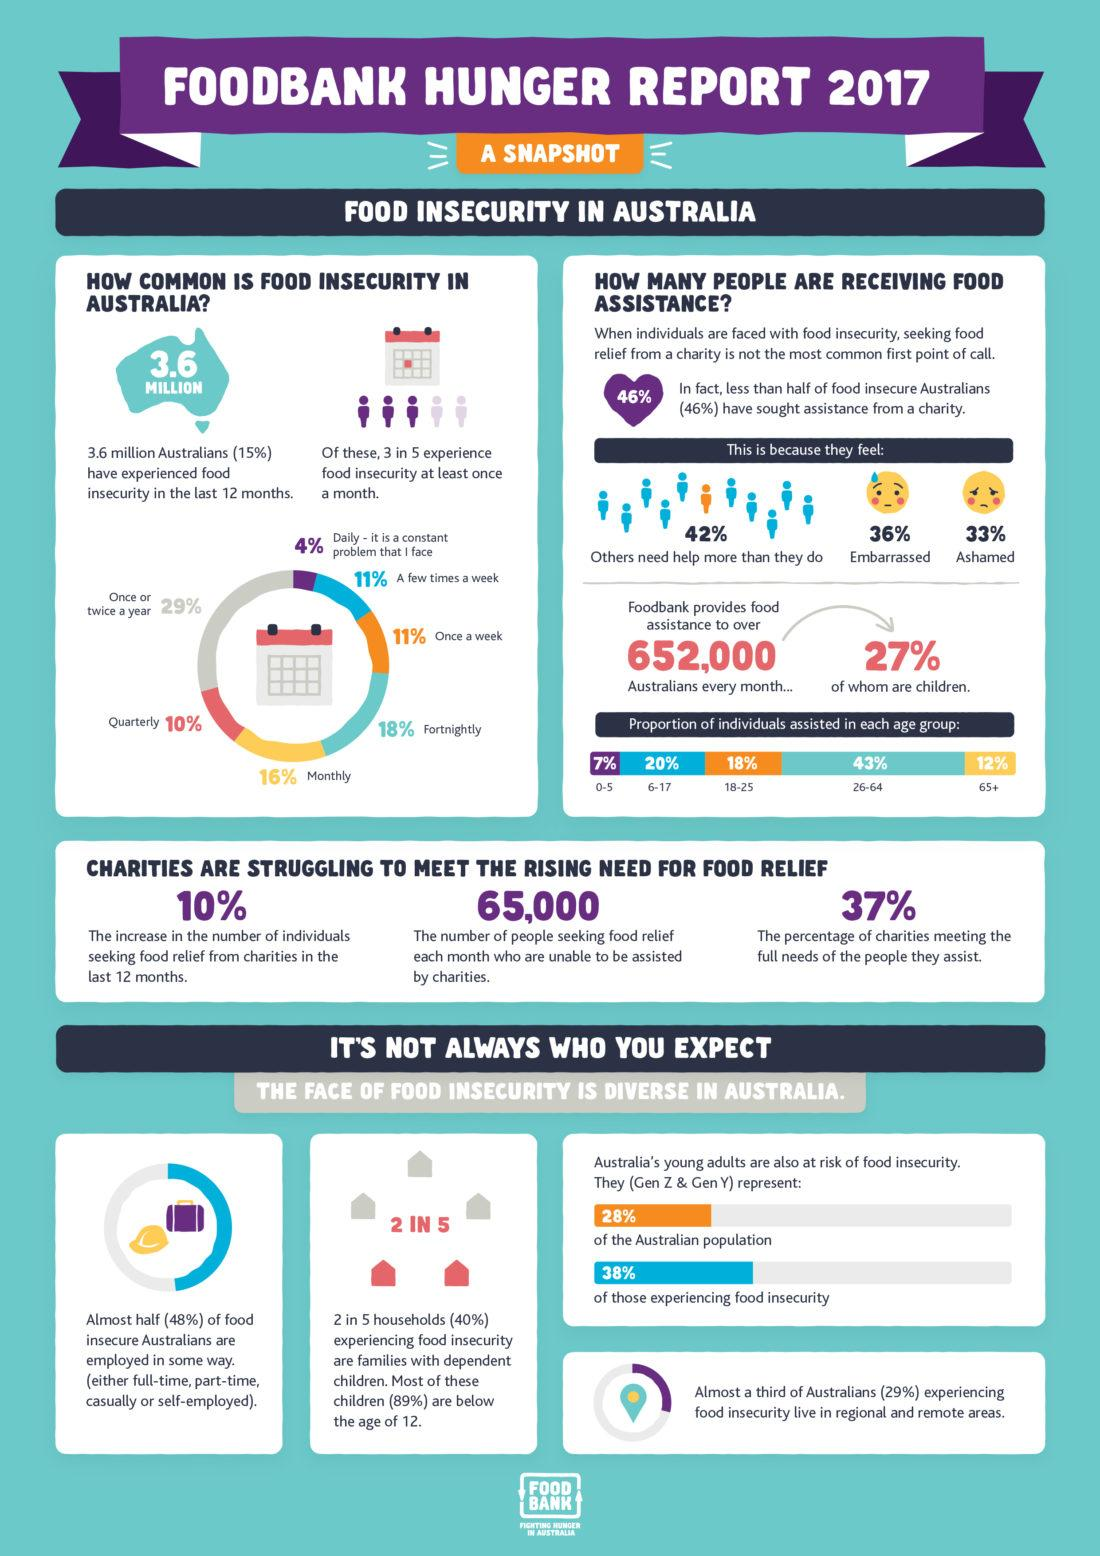Outline some significant characteristics in this image. According to a recent survey, 36% of food insecure Australians reported feeling embarrassed about seeking assistance from a charity. According to a recent survey, 33% of food insecure Australians are too ashamed to seek assistance from a charity. According to recent data, only 37% of charities are successfully meeting the full needs of the people they assist. 